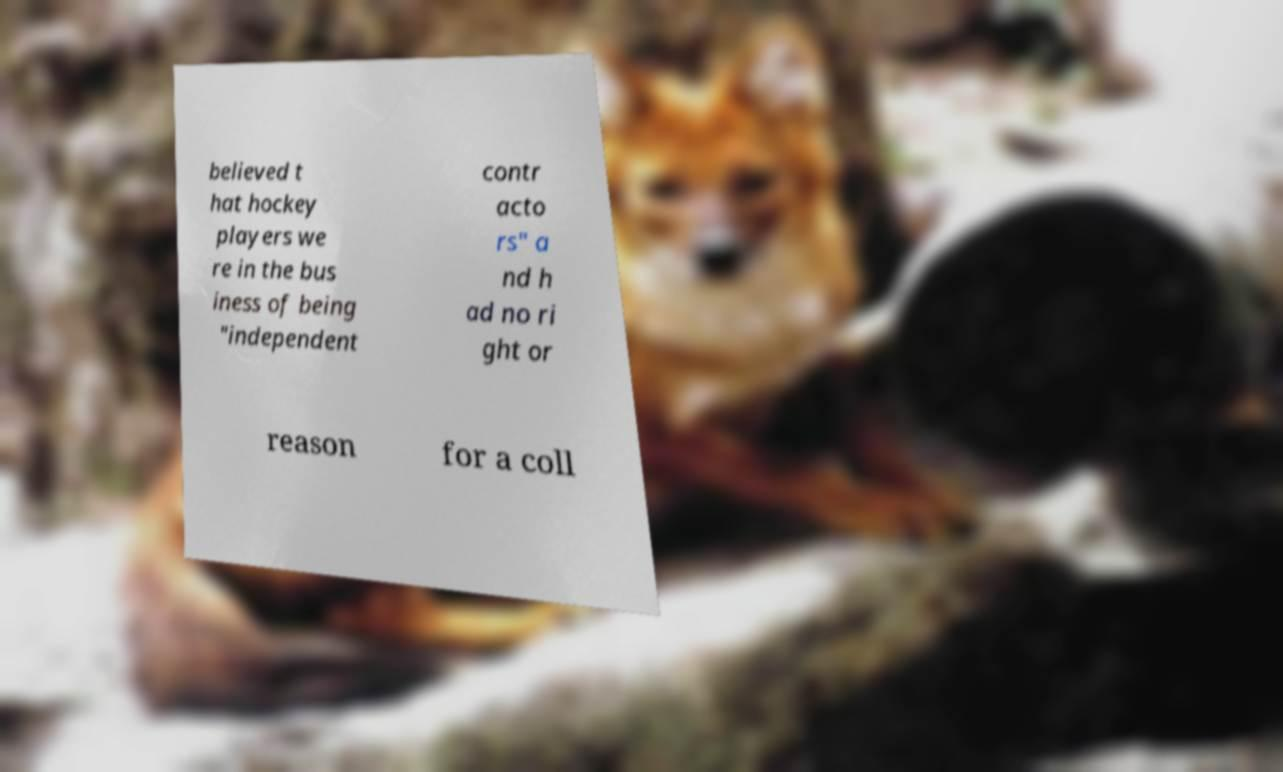Can you accurately transcribe the text from the provided image for me? believed t hat hockey players we re in the bus iness of being "independent contr acto rs" a nd h ad no ri ght or reason for a coll 